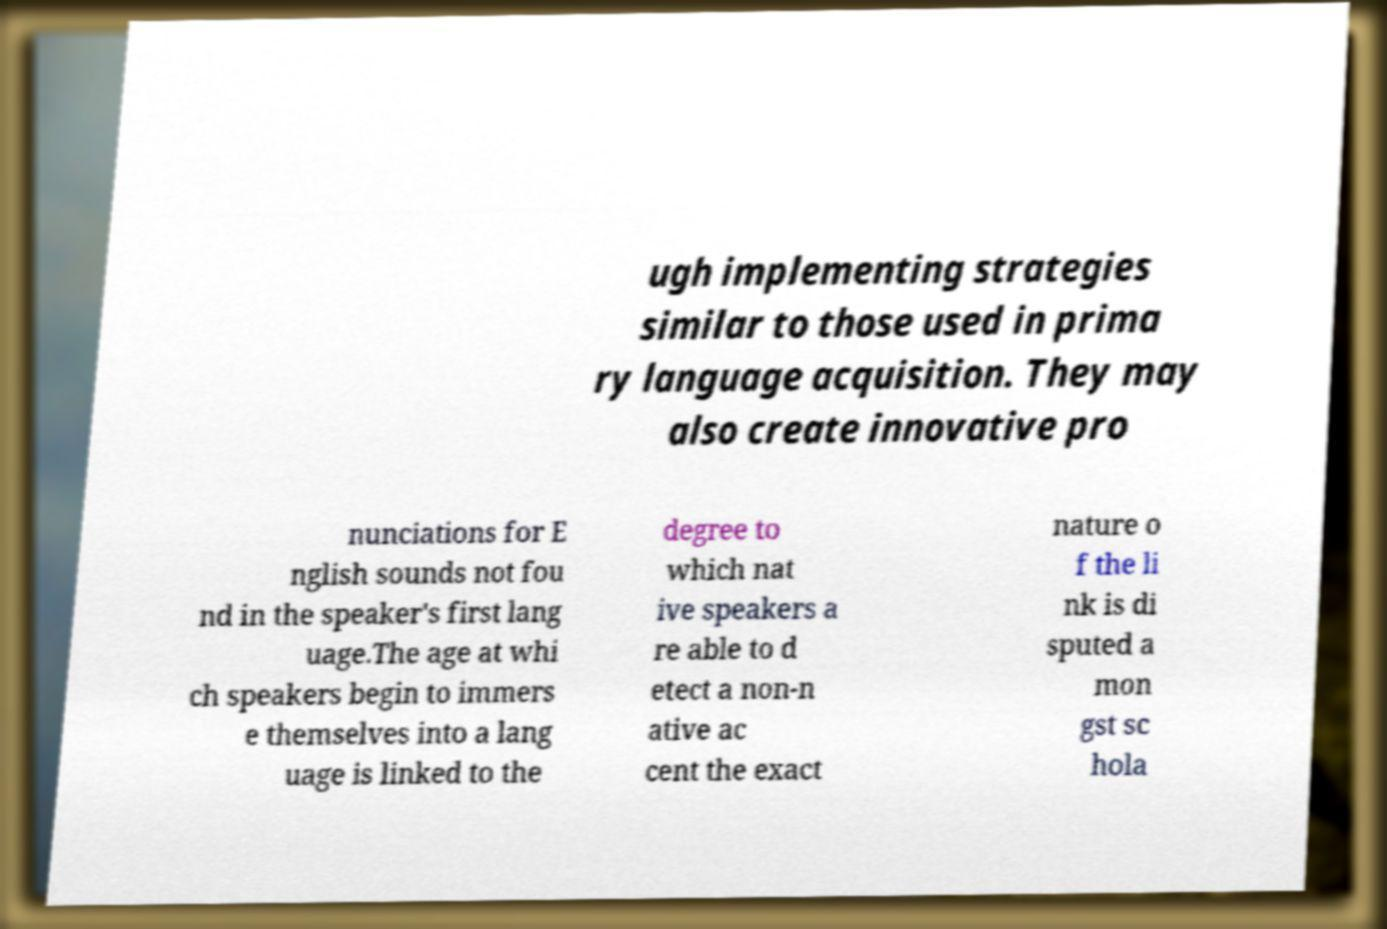Could you assist in decoding the text presented in this image and type it out clearly? ugh implementing strategies similar to those used in prima ry language acquisition. They may also create innovative pro nunciations for E nglish sounds not fou nd in the speaker's first lang uage.The age at whi ch speakers begin to immers e themselves into a lang uage is linked to the degree to which nat ive speakers a re able to d etect a non-n ative ac cent the exact nature o f the li nk is di sputed a mon gst sc hola 